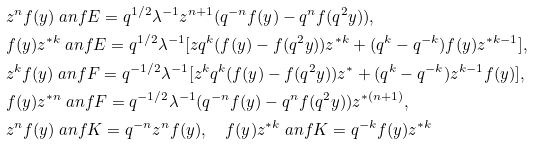<formula> <loc_0><loc_0><loc_500><loc_500>& z ^ { n } f ( y ) \ a n f E = q ^ { 1 / 2 } \lambda ^ { - 1 } z ^ { n + 1 } ( q ^ { - n } f ( y ) - q ^ { n } f ( q ^ { 2 } y ) ) , \\ & f ( y ) z ^ { \ast k } \ a n f E = q ^ { 1 / 2 } \lambda ^ { - 1 } [ z q ^ { k } ( f ( y ) - f ( q ^ { 2 } y ) ) z ^ { \ast k } + ( q ^ { k } - q ^ { - k } ) f ( y ) z ^ { \ast k - 1 } ] , \\ & z ^ { k } f ( y ) \ a n f F = q ^ { - 1 / 2 } \lambda ^ { - 1 } [ z ^ { k } q ^ { k } ( f ( y ) - f ( q ^ { 2 } y ) ) z ^ { \ast } + ( q ^ { k } - q ^ { - k } ) z ^ { k - 1 } f ( y ) ] , \\ & f ( y ) z ^ { \ast n } \ a n f F = q ^ { - 1 / 2 } \lambda ^ { - 1 } ( q ^ { - n } f ( y ) - q ^ { n } f ( q ^ { 2 } y ) ) z ^ { \ast ( n + 1 ) } , \\ & z ^ { n } f ( y ) \ a n f K = q ^ { - n } z ^ { n } f ( y ) , \quad f ( y ) z ^ { \ast k } \ a n f K = q ^ { - k } f ( y ) z ^ { \ast k }</formula> 